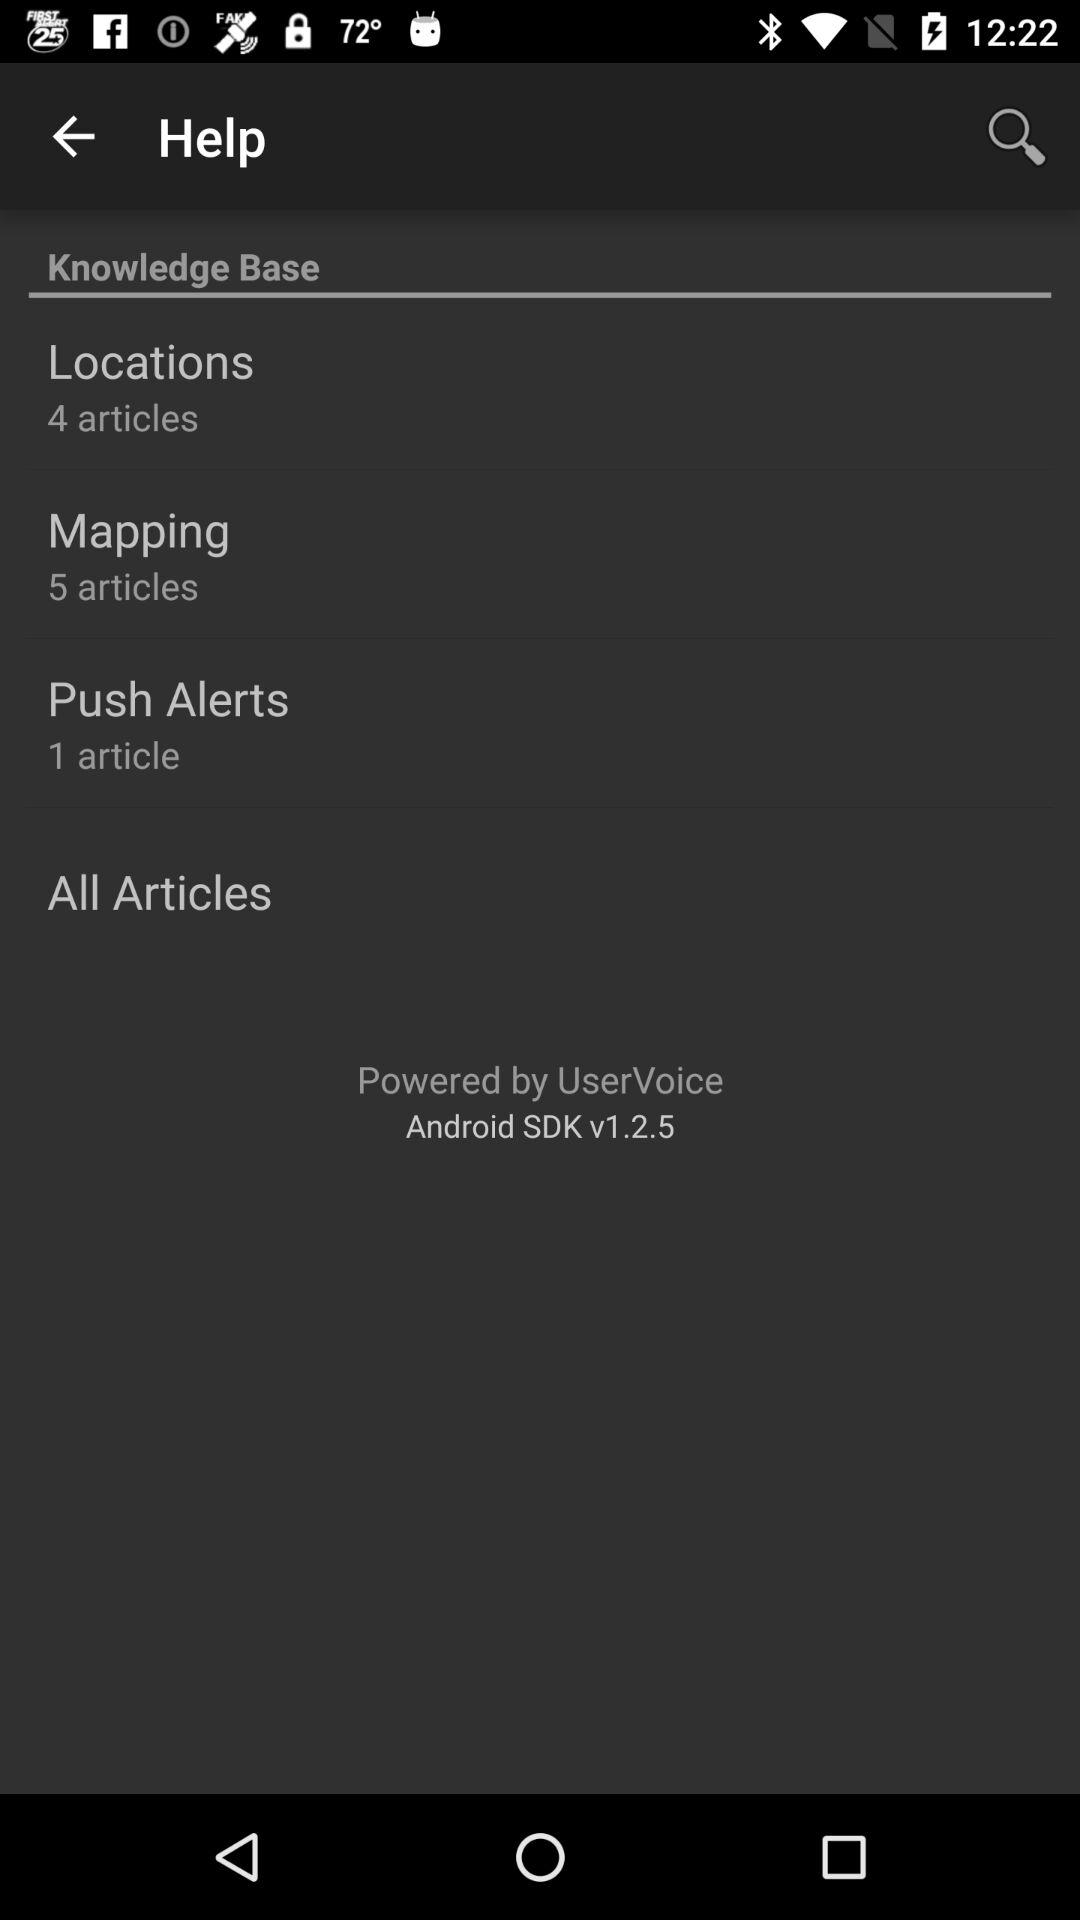How many articles are there in total on the Knowledge Base?
Answer the question using a single word or phrase. 10 